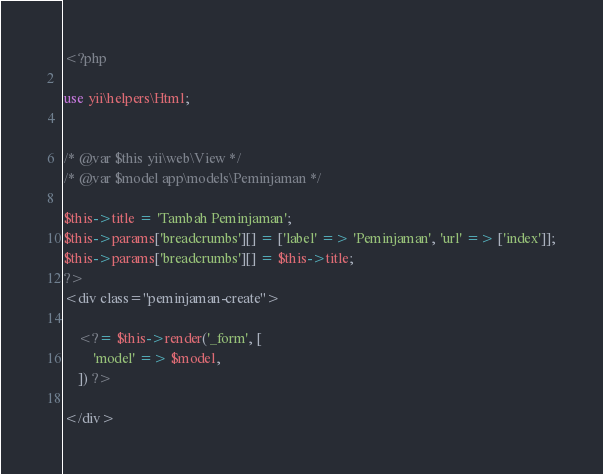Convert code to text. <code><loc_0><loc_0><loc_500><loc_500><_PHP_><?php

use yii\helpers\Html;


/* @var $this yii\web\View */
/* @var $model app\models\Peminjaman */

$this->title = 'Tambah Peminjaman';
$this->params['breadcrumbs'][] = ['label' => 'Peminjaman', 'url' => ['index']];
$this->params['breadcrumbs'][] = $this->title;
?>
<div class="peminjaman-create">

    <?= $this->render('_form', [
        'model' => $model,
    ]) ?>

</div>
</code> 